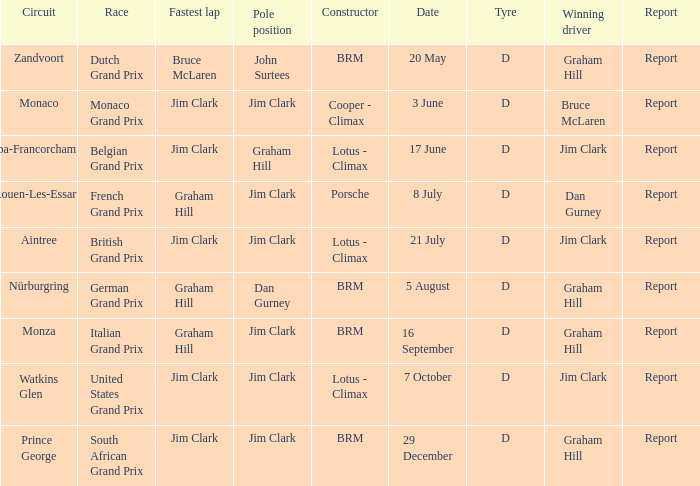What is the constructor at the United States Grand Prix? Lotus - Climax. 